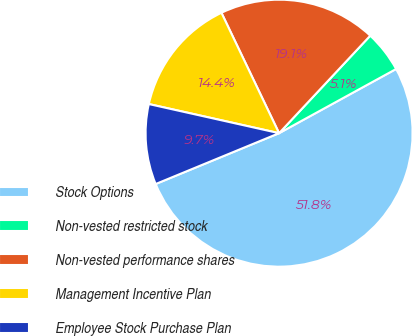Convert chart. <chart><loc_0><loc_0><loc_500><loc_500><pie_chart><fcel>Stock Options<fcel>Non-vested restricted stock<fcel>Non-vested performance shares<fcel>Management Incentive Plan<fcel>Employee Stock Purchase Plan<nl><fcel>51.76%<fcel>5.05%<fcel>19.07%<fcel>14.39%<fcel>9.72%<nl></chart> 